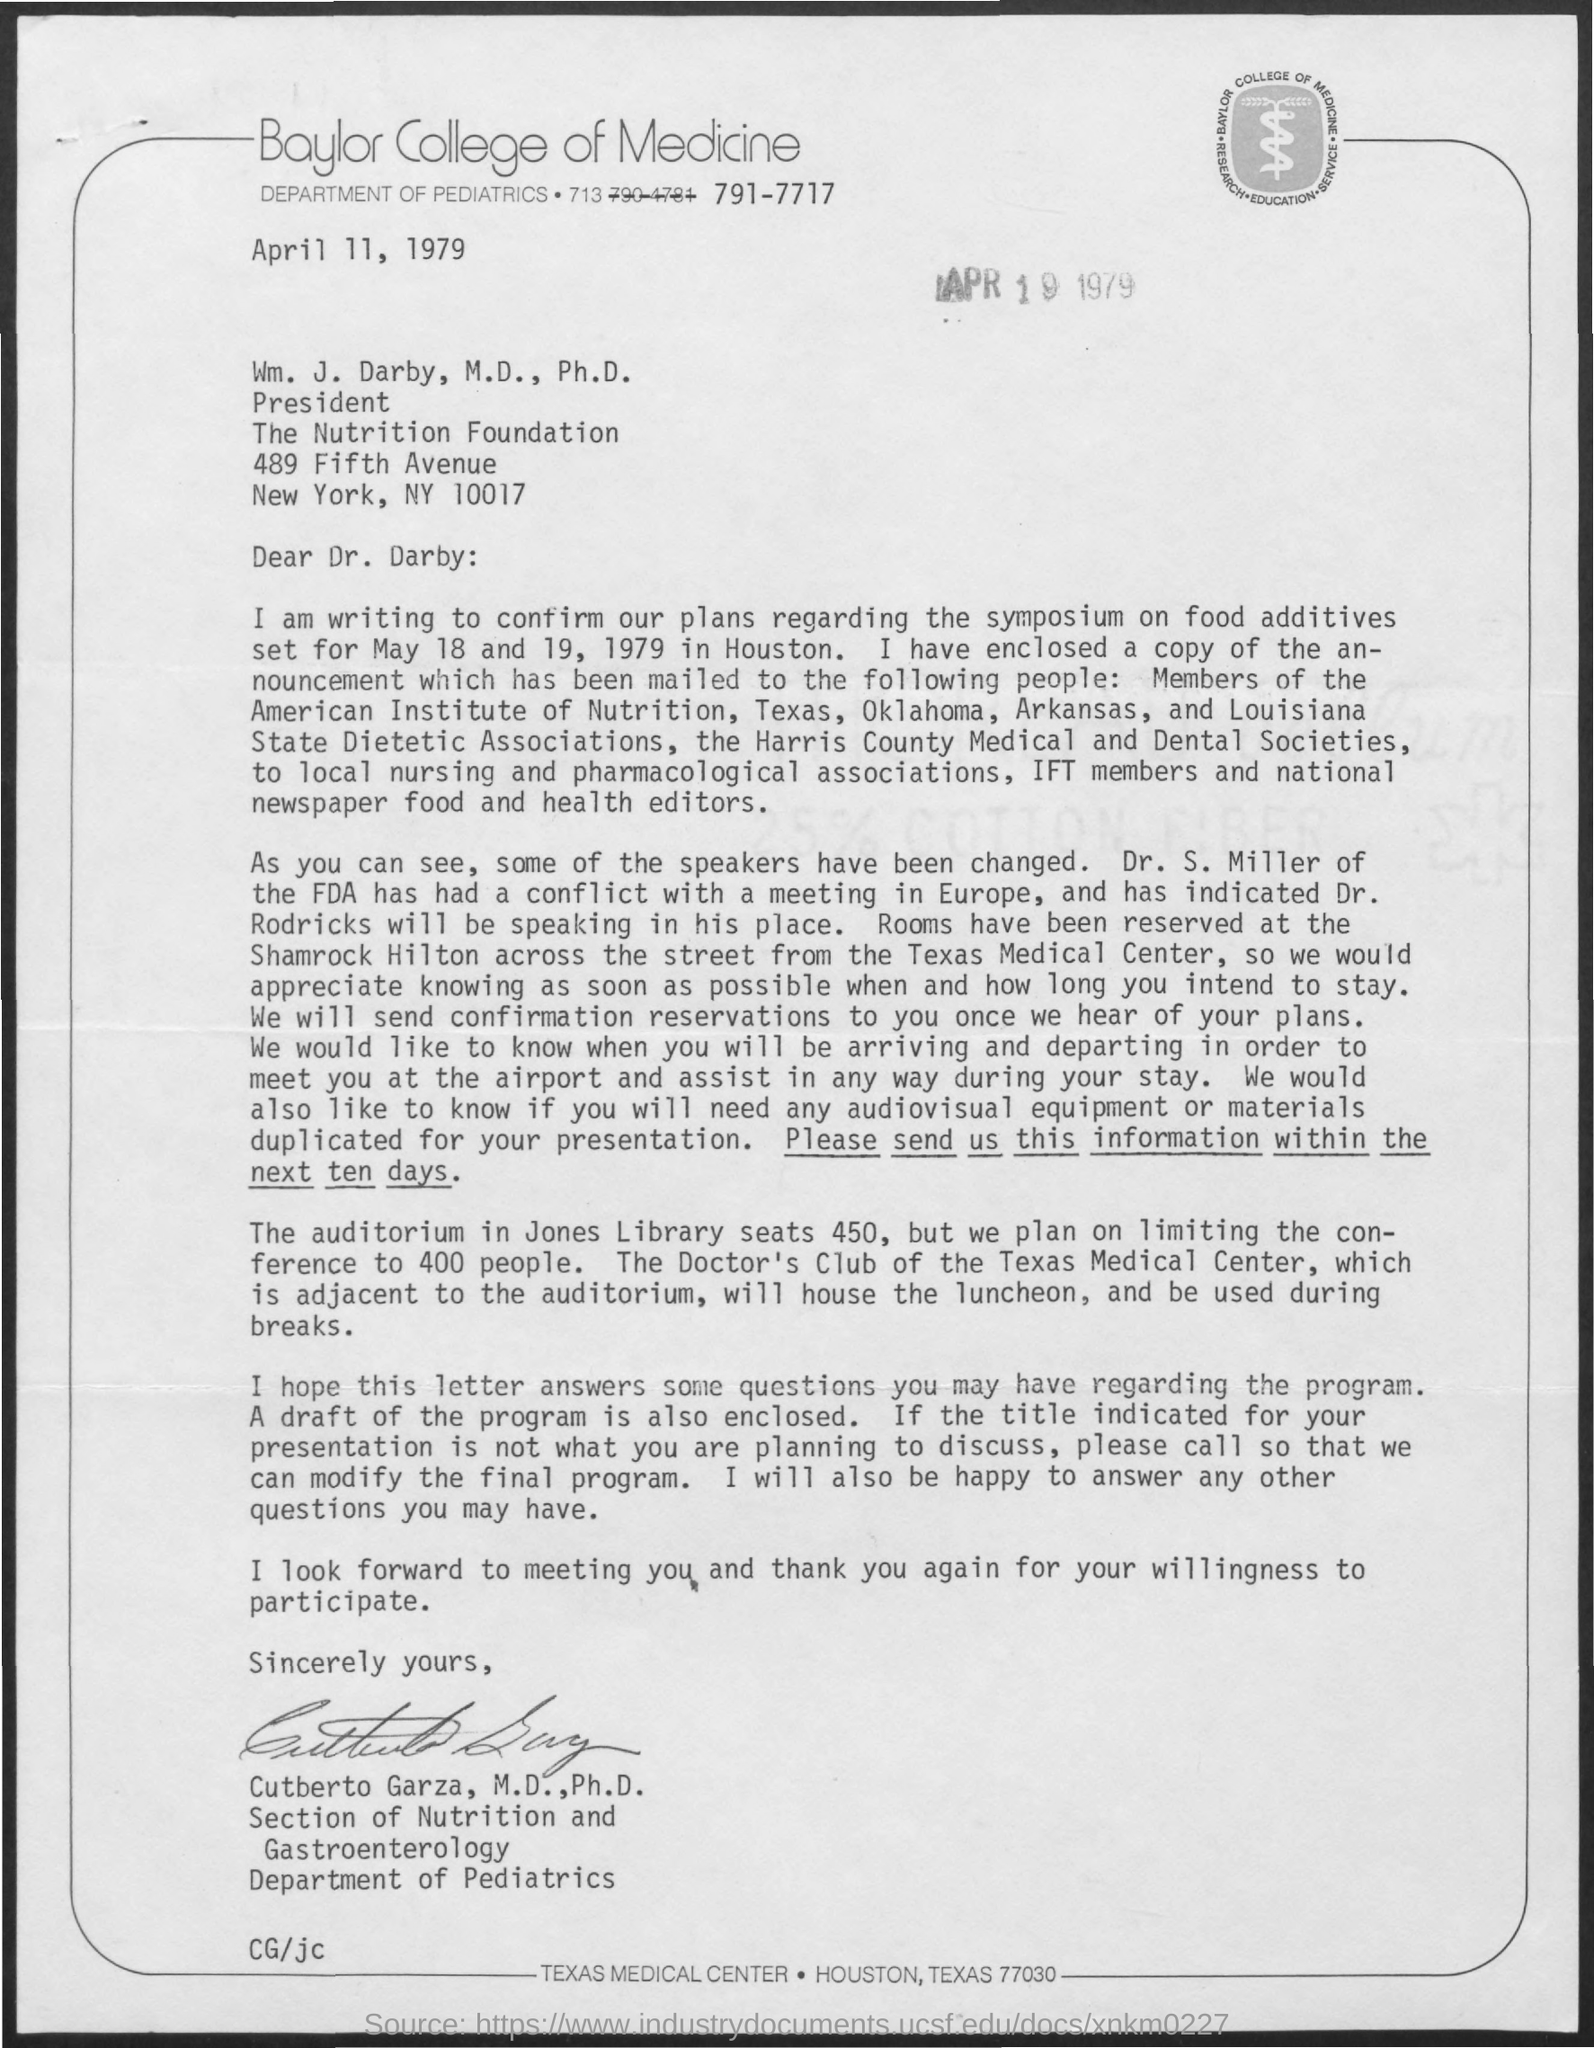Who is speaking in place of Dr. S Miller?
Your answer should be very brief. Dr. Rodricks. 